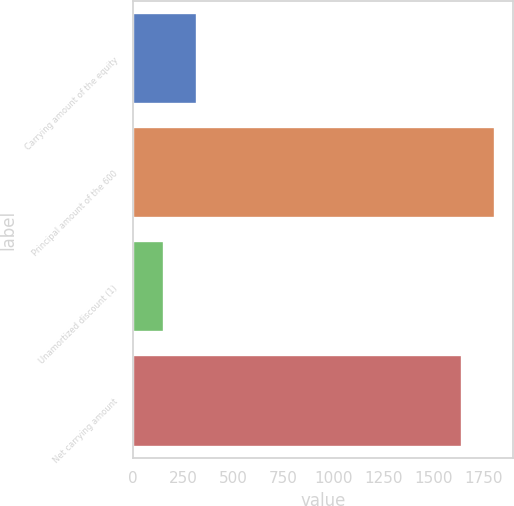Convert chart to OTSL. <chart><loc_0><loc_0><loc_500><loc_500><bar_chart><fcel>Carrying amount of the equity<fcel>Principal amount of the 600<fcel>Unamortized discount (1)<fcel>Net carrying amount<nl><fcel>319.1<fcel>1805.1<fcel>155<fcel>1641<nl></chart> 